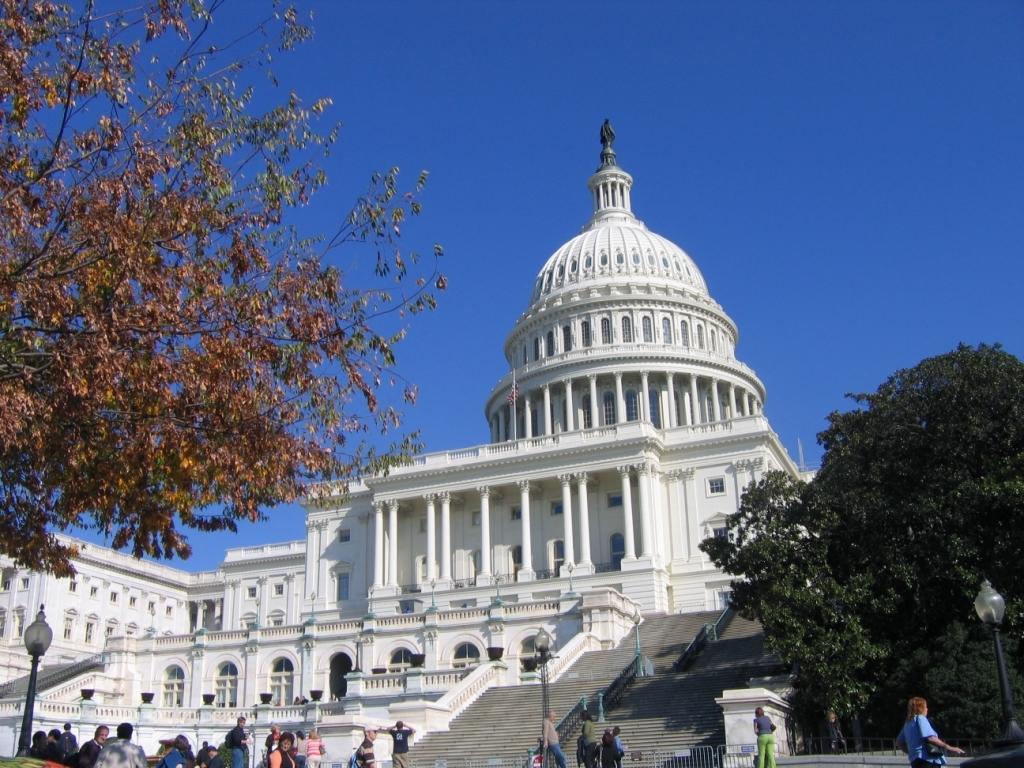Can you describe this image briefly? In this picture we can see building, steps, light poles, people, fence and trees. Background we can see blue sky. 